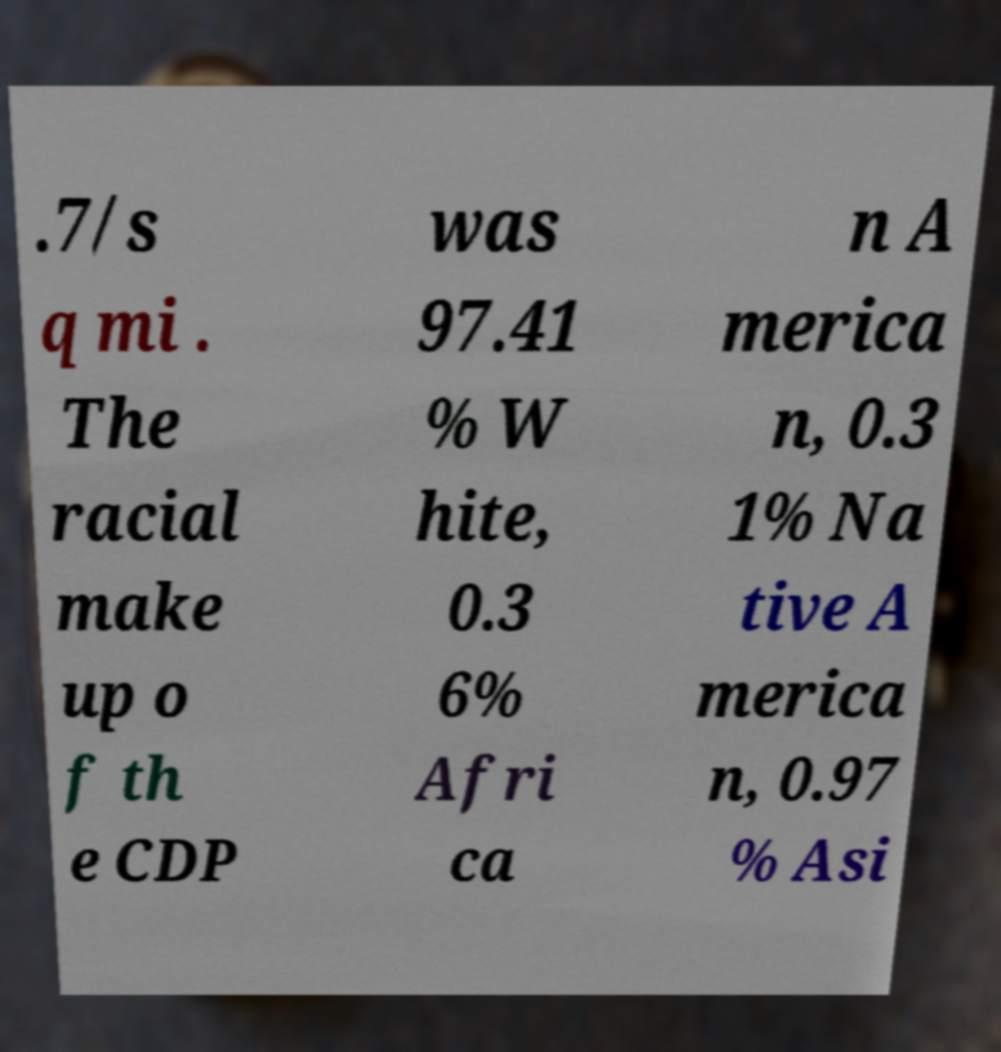For documentation purposes, I need the text within this image transcribed. Could you provide that? .7/s q mi . The racial make up o f th e CDP was 97.41 % W hite, 0.3 6% Afri ca n A merica n, 0.3 1% Na tive A merica n, 0.97 % Asi 